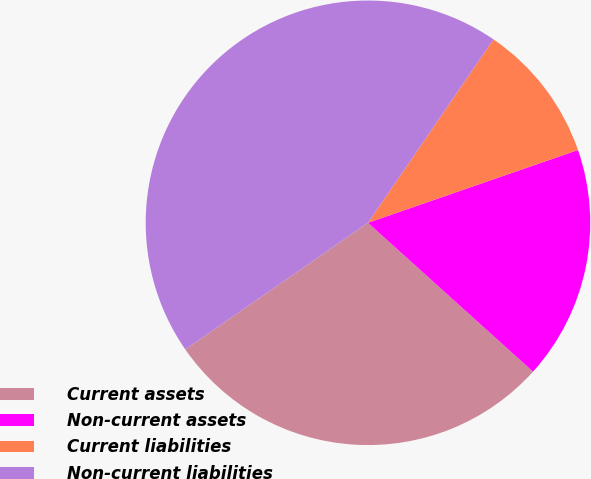Convert chart to OTSL. <chart><loc_0><loc_0><loc_500><loc_500><pie_chart><fcel>Current assets<fcel>Non-current assets<fcel>Current liabilities<fcel>Non-current liabilities<nl><fcel>28.67%<fcel>16.99%<fcel>10.14%<fcel>44.2%<nl></chart> 